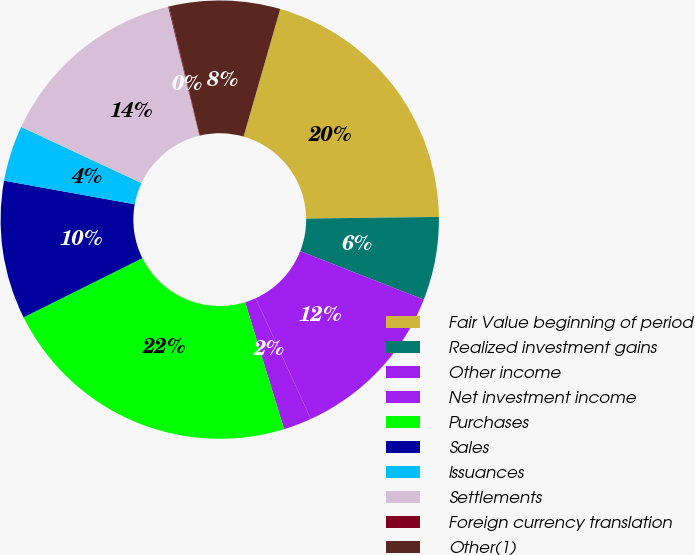<chart> <loc_0><loc_0><loc_500><loc_500><pie_chart><fcel>Fair Value beginning of period<fcel>Realized investment gains<fcel>Other income<fcel>Net investment income<fcel>Purchases<fcel>Sales<fcel>Issuances<fcel>Settlements<fcel>Foreign currency translation<fcel>Other(1)<nl><fcel>20.35%<fcel>6.14%<fcel>12.23%<fcel>2.08%<fcel>22.38%<fcel>10.2%<fcel>4.11%<fcel>14.26%<fcel>0.06%<fcel>8.17%<nl></chart> 